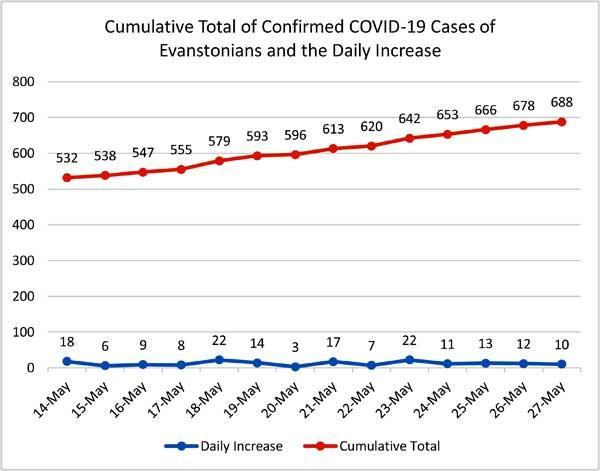What is the total daily increase on the 26th and 27th of May?
Answer the question with a short phrase. 22 What is the total daily increase on the 24th and 25th of May? 24 What is the total daily increase and cumulative total on 27th May, taken together? 698 